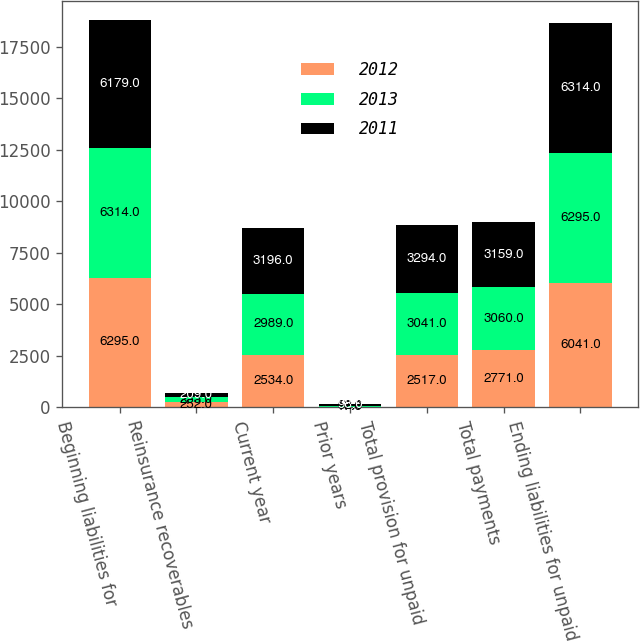Convert chart to OTSL. <chart><loc_0><loc_0><loc_500><loc_500><stacked_bar_chart><ecel><fcel>Beginning liabilities for<fcel>Reinsurance recoverables<fcel>Current year<fcel>Prior years<fcel>Total provision for unpaid<fcel>Total payments<fcel>Ending liabilities for unpaid<nl><fcel>2012<fcel>6295<fcel>252<fcel>2534<fcel>17<fcel>2517<fcel>2771<fcel>6041<nl><fcel>2013<fcel>6314<fcel>233<fcel>2989<fcel>52<fcel>3041<fcel>3060<fcel>6295<nl><fcel>2011<fcel>6179<fcel>209<fcel>3196<fcel>98<fcel>3294<fcel>3159<fcel>6314<nl></chart> 